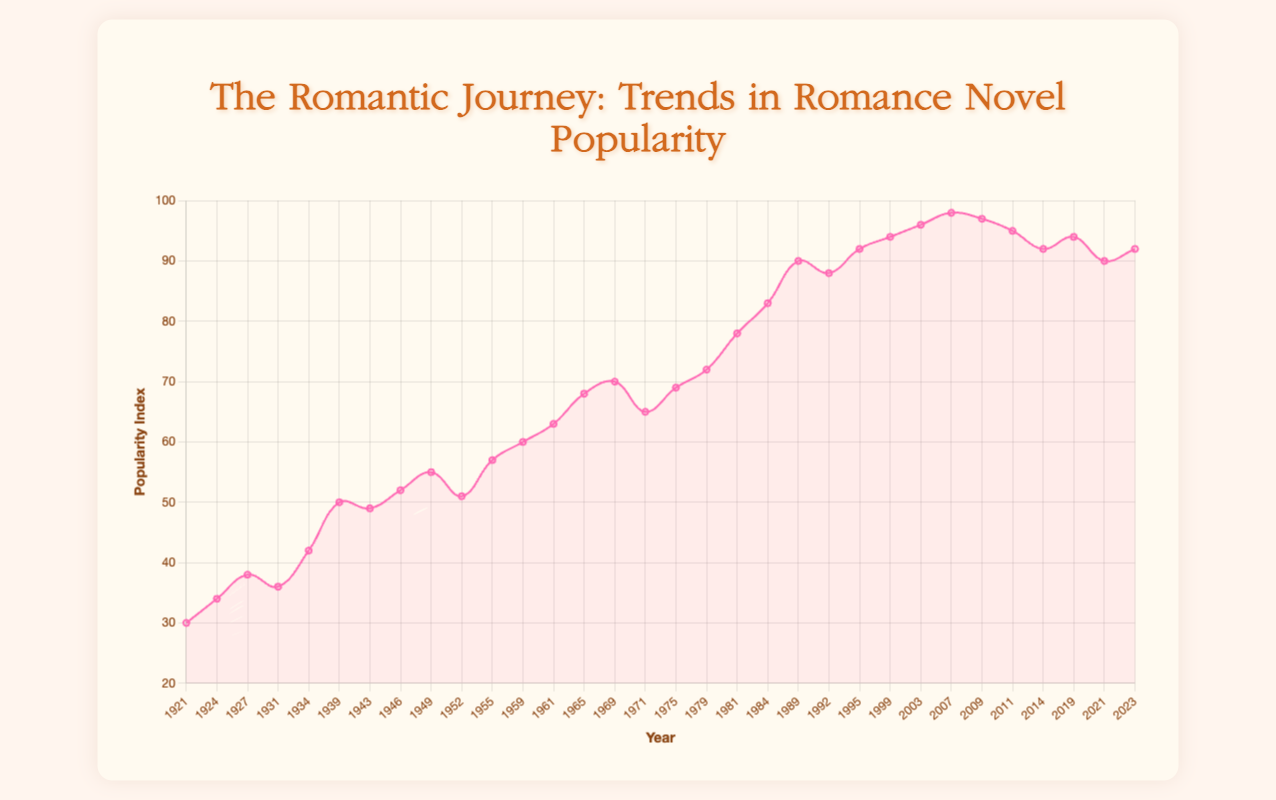What is the general trend in the popularity of romance novels from the 1920s to the 2020s? The general trend in the popularity of romance novels from the 1920s to the 2020s shows a consistent increase. Starting from a popularity index of 30 in 1921 and rising to a peak of 98 in 2007, the popularity has seen overall growth. The index dips slightly in the 2010s and 2020s but remains high.
Answer: Increasing Which decade experienced the highest peak in romance novel popularity index? From the data, the highest peak in the romance novel popularity index occurs in the 2000s, specifically in the year 2007 with an index of 98 ("Twilight by Stephenie Meyer").
Answer: 2000s Compare the popularity index between 1927 and 2023. Which year had a higher index, and by how much? The popularity index in 1927 is 38 and in 2023 it is 92. To find the difference, subtract 38 from 92, resulting in a difference of 54. Therefore, 2023 had a higher index by 54 points.
Answer: 2023 by 54 points In which year did the popularity index reach 70 for the first time, and which notable work is associated with that year? The popularity index reached 70 for the first time in the year 1969. The notable work associated with that year is "Portnoy's Complaint by Philip Roth".
Answer: 1969, "Portnoy's Complaint" What is the difference in the popularity index between the highest point in the 1980s and the lowest point in the 1990s? In the 1980s, the highest point reached a popularity index of 90 in 1989 ("Whitney, My Love by Judith McNaught"). In the 1990s, the lowest point was 88 in 1992 ("Outlander by Diana Gabaldon"). The difference is 90 - 88 = 2.
Answer: 2 During which years in the 2010s did the popularity index drop to 92, and which notable works were published in those years? The popularity index dropped to 92 in the year 2014 and in 2023. The notable work published in 2014 was "Me Before You by Jojo Moyes", and in 2023, it was "Beach Read by Emily Henry".
Answer: 2014 and 2023, "Me Before You" and "Beach Read" Between which consecutive decades was the largest increase in the popularity index observed? The largest increase between consecutive decades was observed from the 1970s (highest index of 72) to the 1980s (highest index of 90). The increase is calculated as 90 - 72 = 18.
Answer: Between the 1970s and 1980s How many years saw the popularity index reach or exceed 90? Name them. The years that saw the popularity index reach or exceed 90 are: 1989, 1992, 1995, 1999, 2003, 2007, 2009, 2011, 2019, and 2021. This totals to 10 years.
Answer: 10 years: 1989, 1992, 1995, 1999, 2003, 2007, 2009, 2011, 2019, 2021 